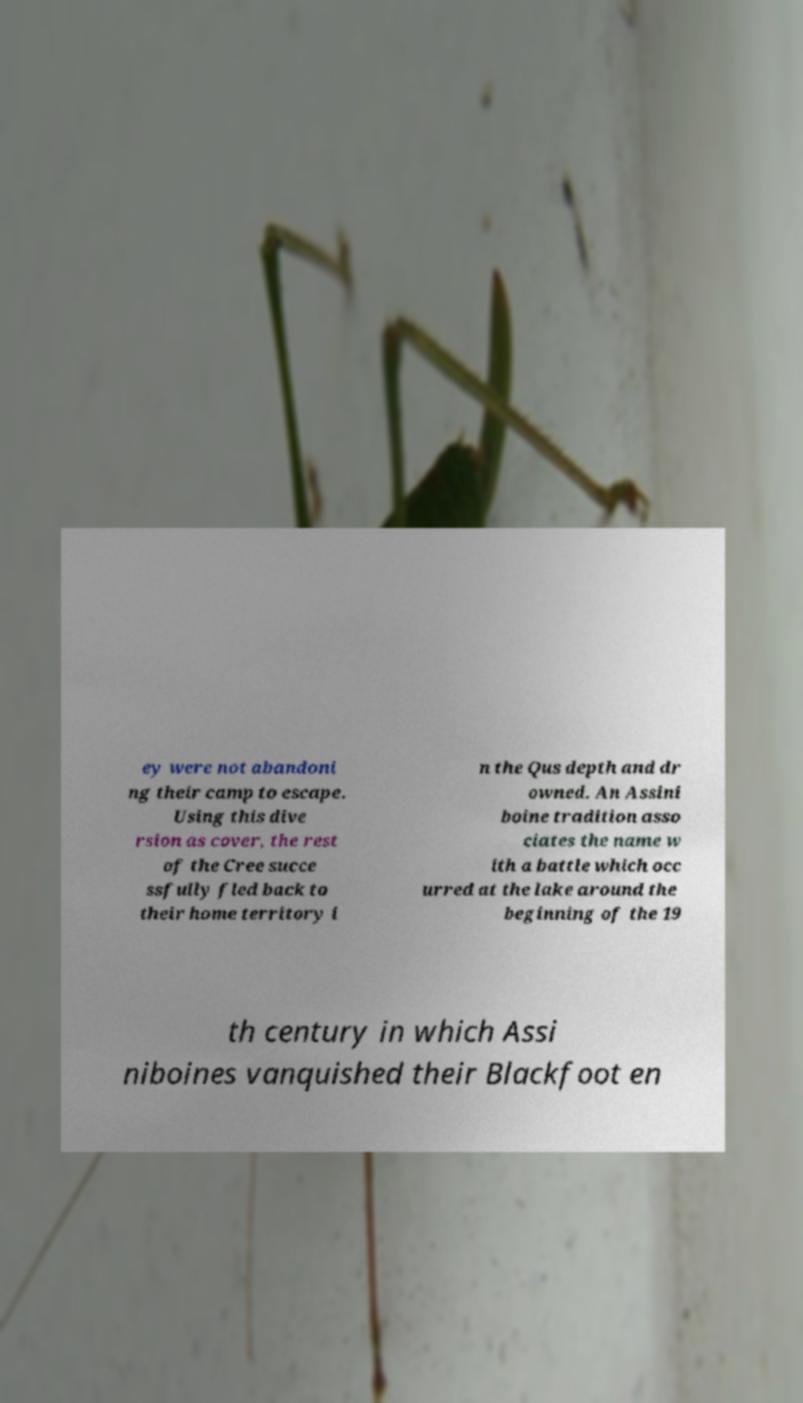Could you assist in decoding the text presented in this image and type it out clearly? ey were not abandoni ng their camp to escape. Using this dive rsion as cover, the rest of the Cree succe ssfully fled back to their home territory i n the Qus depth and dr owned. An Assini boine tradition asso ciates the name w ith a battle which occ urred at the lake around the beginning of the 19 th century in which Assi niboines vanquished their Blackfoot en 